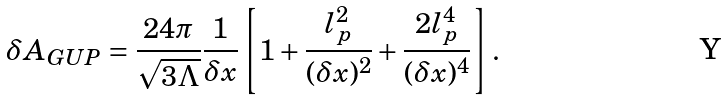Convert formula to latex. <formula><loc_0><loc_0><loc_500><loc_500>\delta A _ { G U P } = \frac { 2 4 \pi } { \sqrt { 3 \Lambda } } \frac { 1 } { \delta x } \left [ 1 + \frac { l _ { p } ^ { 2 } } { ( \delta x ) ^ { 2 } } + \frac { 2 l _ { p } ^ { 4 } } { ( \delta x ) ^ { 4 } } \right ] .</formula> 